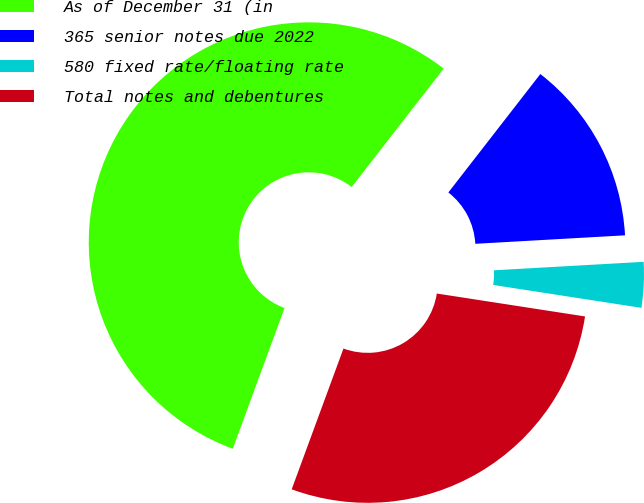<chart> <loc_0><loc_0><loc_500><loc_500><pie_chart><fcel>As of December 31 (in<fcel>365 senior notes due 2022<fcel>580 fixed rate/floating rate<fcel>Total notes and debentures<nl><fcel>54.9%<fcel>13.59%<fcel>3.34%<fcel>28.17%<nl></chart> 